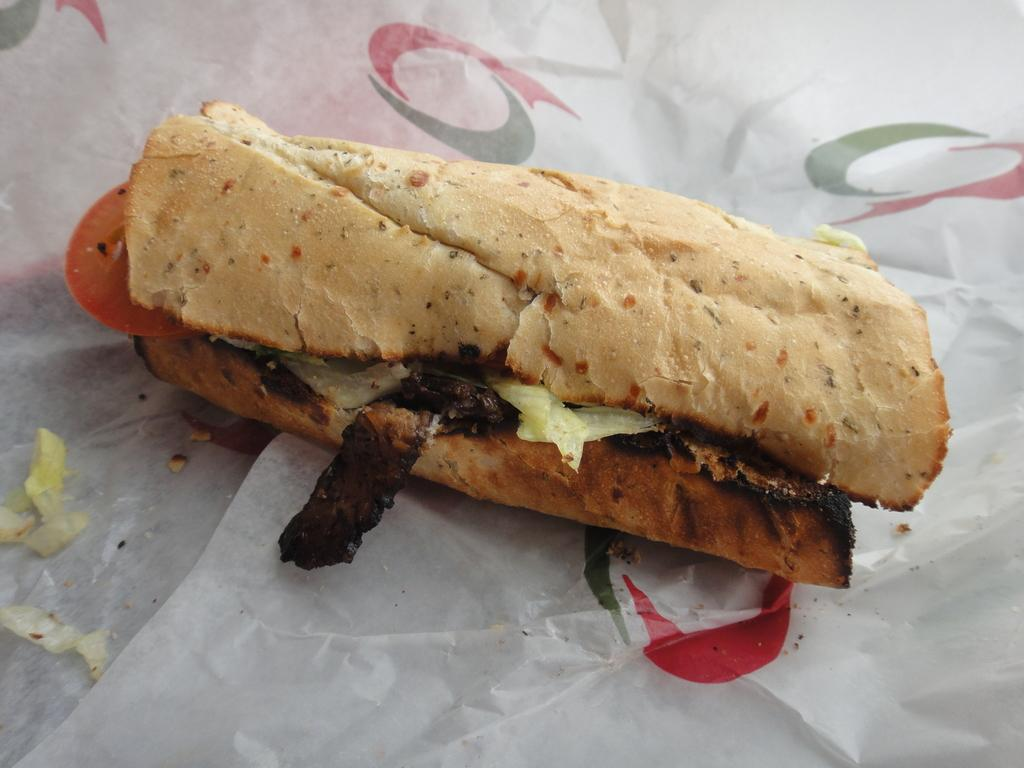What is the main subject of the image? There is a food item in the image. How is the food item presented in the image? The food item is placed on a paper. What type of pump is visible in the image? There is no pump present in the image; it features a food item placed on a paper. 